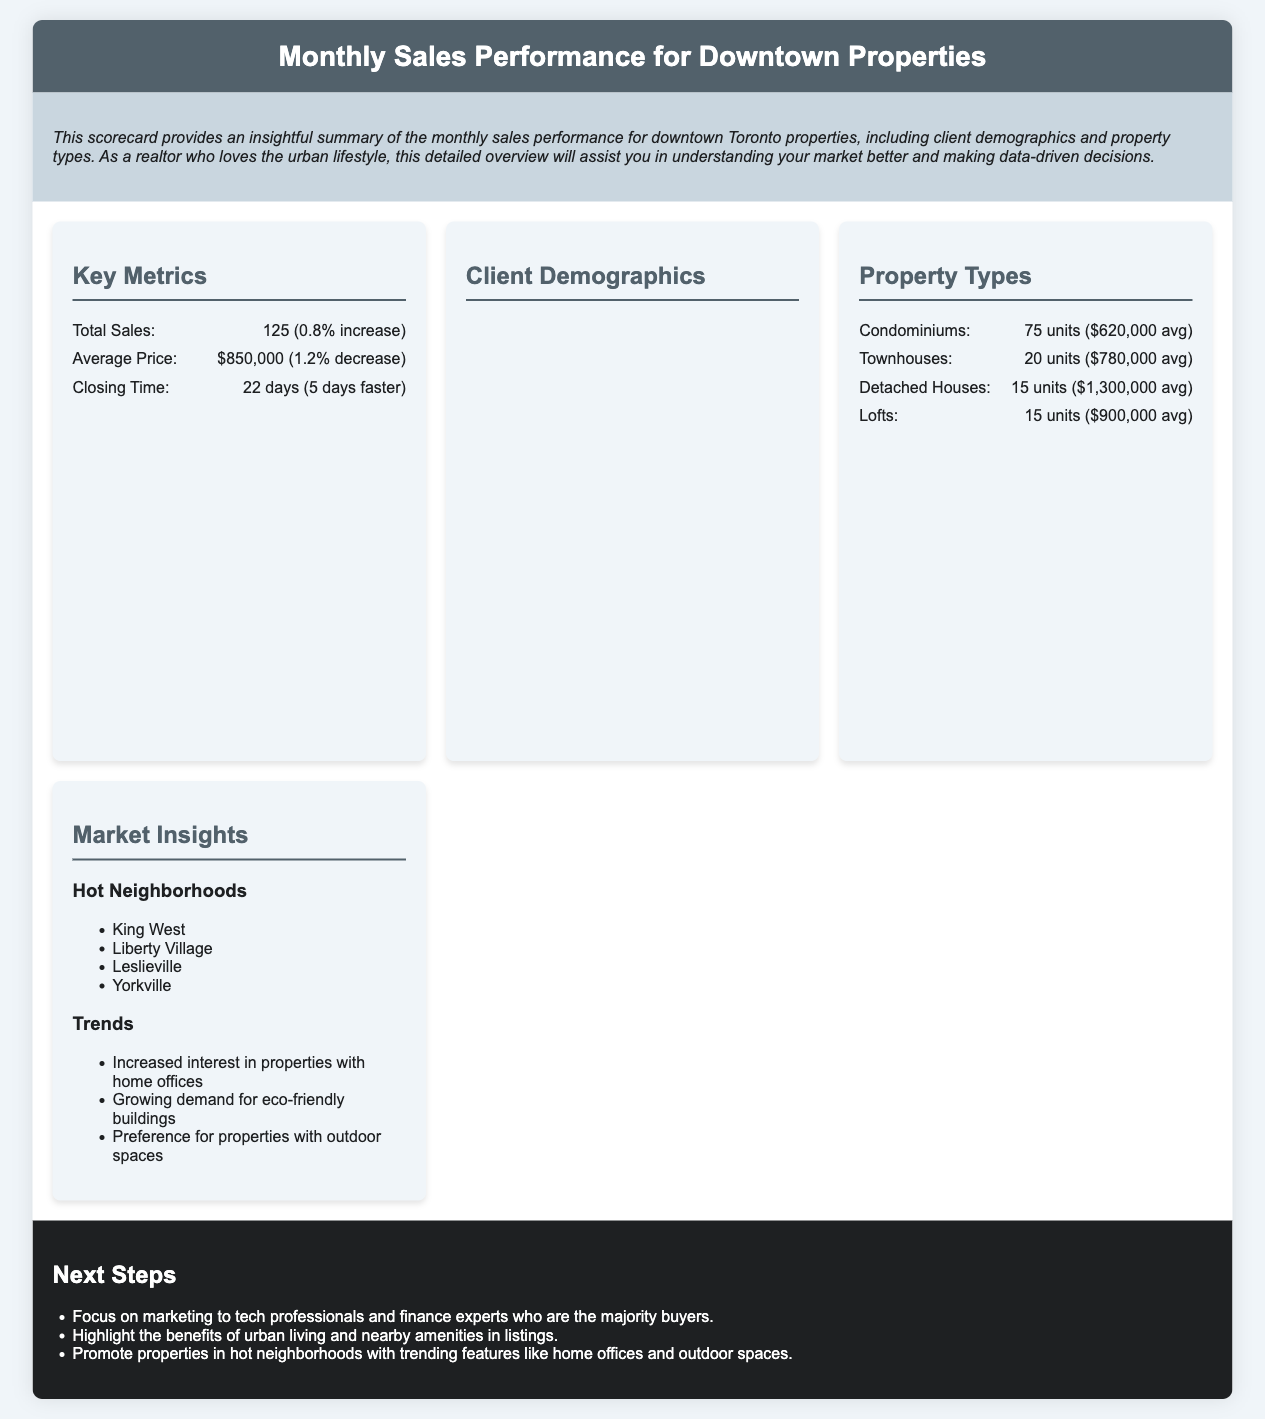What was the total number of sales? The total number of sales is provided in the Key Metrics section as 125.
Answer: 125 What was the average price of properties sold? The average price is found in the Key Metrics section, which states $850,000.
Answer: $850,000 How many condominiums were sold? The number of condominiums sold is detailed in the Property Types section, which lists 75 units.
Answer: 75 units Which neighborhood is mentioned as hot in the Market Insights? The hot neighborhoods are listed in the Market Insights section, with "King West" being one of them.
Answer: King West What is the closing time mentioned in the Key Metrics? The closing time is stated as 22 days in the Key Metrics section.
Answer: 22 days What is the percentage increase in total sales from last month? The percentage increase in total sales is specified as 0.8% in the Key Metrics section.
Answer: 0.8% How many buyers are aged between 20 to 30? The age distribution indicates that 35% of buyers are in the 20-30 age group.
Answer: 35% Which occupation has the highest percentage of buyers? The occupation with the highest percentage listed in the document is "Tech Professionals" at 30%.
Answer: Tech Professionals What is one of the recommendations for next steps? The recommendations mention focusing on marketing to tech professionals, which is a specific suggestion made in the Next Steps section.
Answer: Focus on marketing to tech professionals 